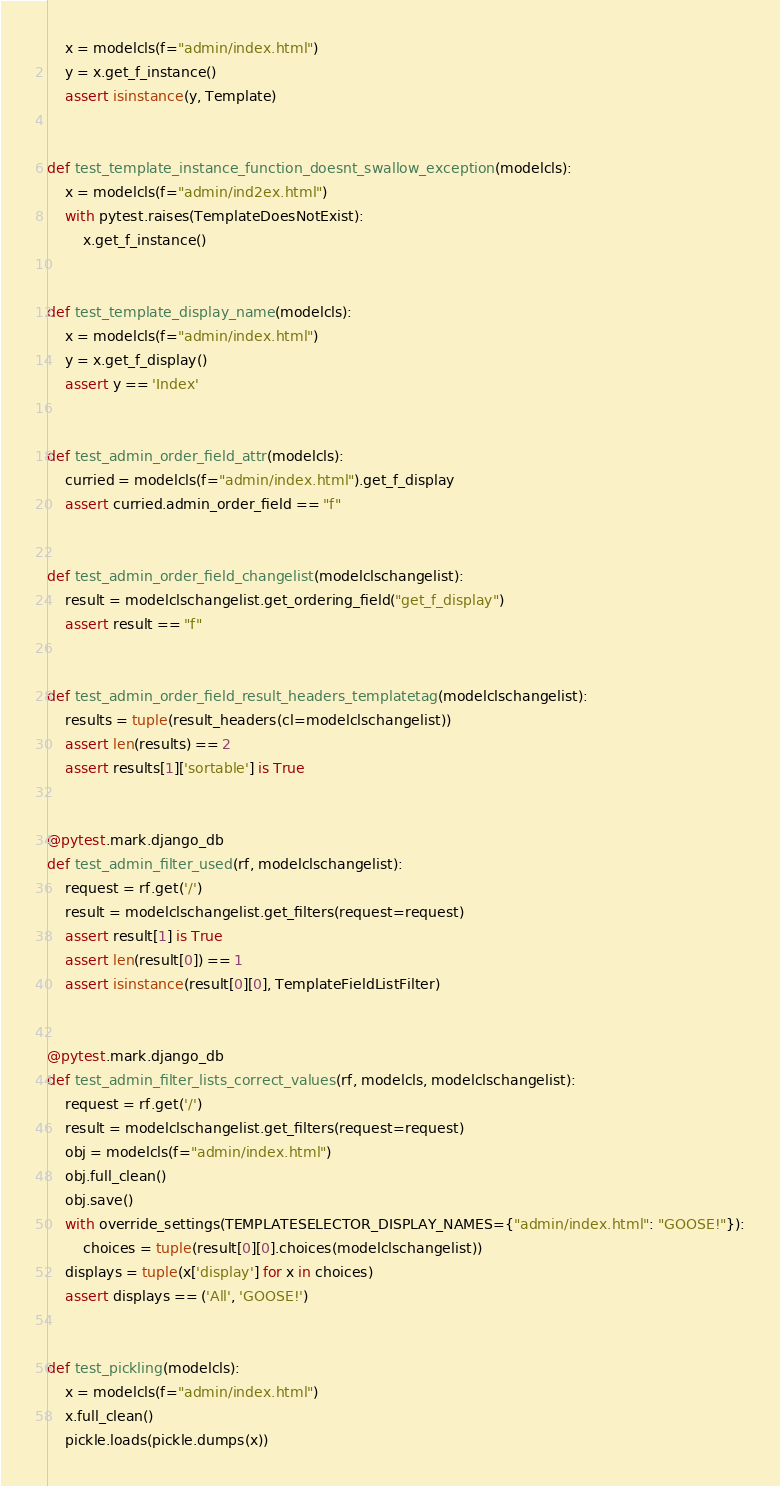Convert code to text. <code><loc_0><loc_0><loc_500><loc_500><_Python_>    x = modelcls(f="admin/index.html")
    y = x.get_f_instance()
    assert isinstance(y, Template)


def test_template_instance_function_doesnt_swallow_exception(modelcls):
    x = modelcls(f="admin/ind2ex.html")
    with pytest.raises(TemplateDoesNotExist):
        x.get_f_instance()


def test_template_display_name(modelcls):
    x = modelcls(f="admin/index.html")
    y = x.get_f_display()
    assert y == 'Index'


def test_admin_order_field_attr(modelcls):
    curried = modelcls(f="admin/index.html").get_f_display
    assert curried.admin_order_field == "f"


def test_admin_order_field_changelist(modelclschangelist):
    result = modelclschangelist.get_ordering_field("get_f_display")
    assert result == "f"


def test_admin_order_field_result_headers_templatetag(modelclschangelist):
    results = tuple(result_headers(cl=modelclschangelist))
    assert len(results) == 2
    assert results[1]['sortable'] is True


@pytest.mark.django_db
def test_admin_filter_used(rf, modelclschangelist):
    request = rf.get('/')
    result = modelclschangelist.get_filters(request=request)
    assert result[1] is True
    assert len(result[0]) == 1
    assert isinstance(result[0][0], TemplateFieldListFilter)


@pytest.mark.django_db
def test_admin_filter_lists_correct_values(rf, modelcls, modelclschangelist):
    request = rf.get('/')
    result = modelclschangelist.get_filters(request=request)
    obj = modelcls(f="admin/index.html")
    obj.full_clean()
    obj.save()
    with override_settings(TEMPLATESELECTOR_DISPLAY_NAMES={"admin/index.html": "GOOSE!"}):
        choices = tuple(result[0][0].choices(modelclschangelist))
    displays = tuple(x['display'] for x in choices)
    assert displays == ('All', 'GOOSE!')


def test_pickling(modelcls):
    x = modelcls(f="admin/index.html")
    x.full_clean()
    pickle.loads(pickle.dumps(x))
</code> 